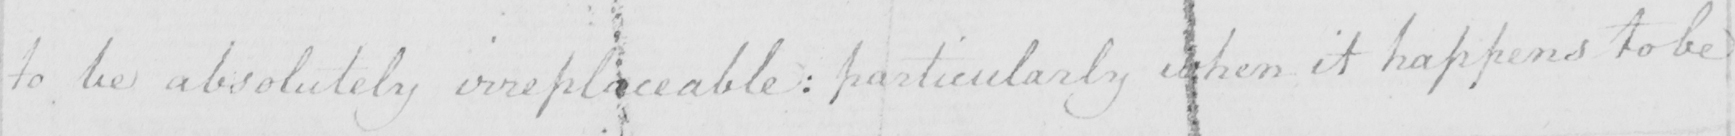Can you read and transcribe this handwriting? to be absolutely irreplaceable :  particularly when it happens to be 